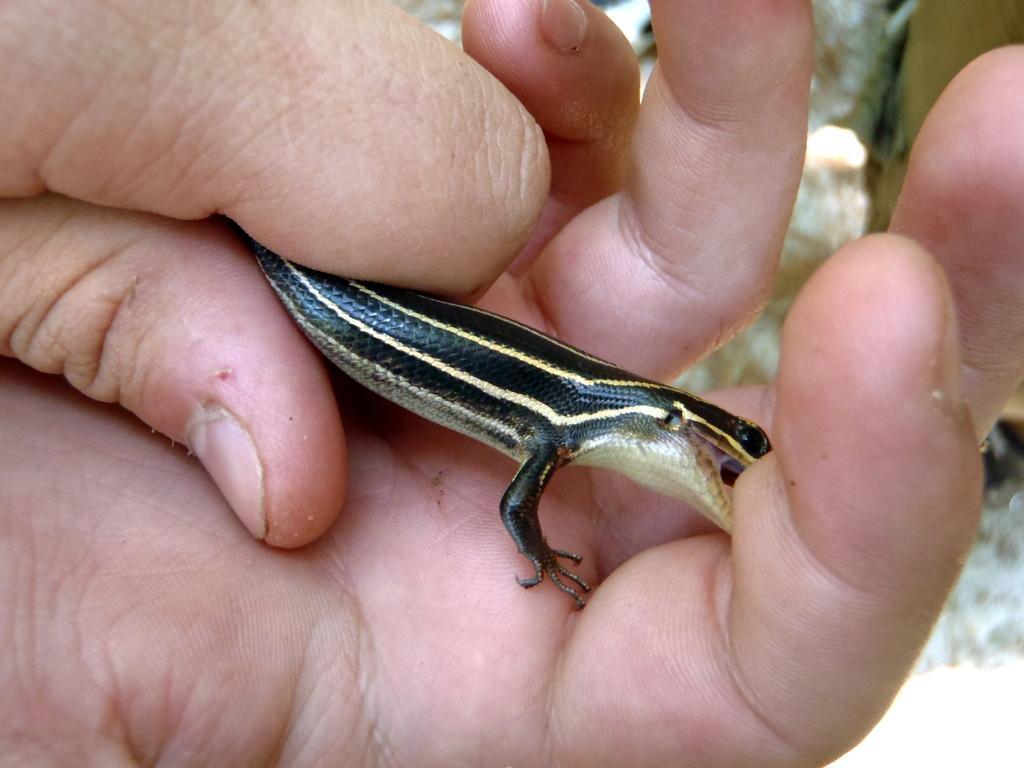Could you give a brief overview of what you see in this image? In this picture we can see a reptile in hands. 